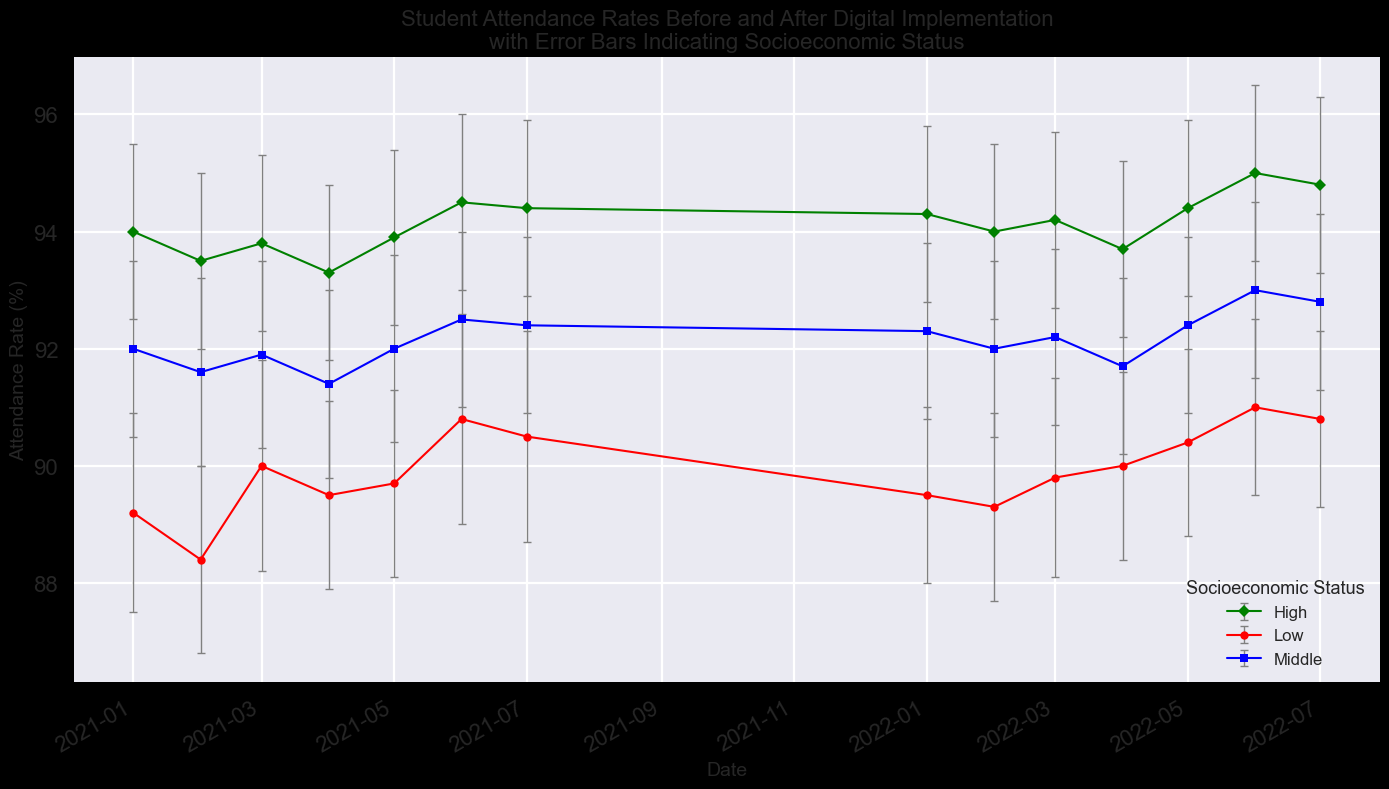What is the general trend in attendance rates for low socioeconomic status students before and after digital implementation? The general trend can be observed by looking at the correlation between dates and attendance rates for low socioeconomic status students. Both before and after digital implementation, the attendance rates show a slight increase month over month. Before implementation (up to July 2021), the rates ranged from approximately 89% to 90.5%. After implementation, the rates improved a bit, ranging from about 89.5% to 92.5%.
Answer: Slight increase How do attendance rates of students from high socioeconomic status compare in July 2021 and July 2022? Attendance rates in July 2021 for high socioeconomic status can be directly compared with July 2022. In July 2021, the mean attendance rate was 94.4%, and in July 2022, it was about 94.8%. Therefore, there's a slight increase in attendance rates for high SES students.
Answer: Increased Which socioeconomic group has the largest error bars? The size of error bars indicates the range of variability in the attendance rates. By visually comparing the error bars across different groups, it can be seen that the High socioeconomic status group has the largest error bars, indicating more variability in the attendance rates.
Answer: High By how much did the mean attendance rate for middle socioeconomic status students change from June 2021 to June 2022? To find the change, compare the mean attendance rate in June 2021 (about 92.5%) to June 2022 (about 93.0%). Calculate the difference: 93.0% - 92.5% = 0.5%.
Answer: 0.5% What is the average mean attendance rate of high socioeconomic status students over the entire period shown? To calculate the average, sum the mean attendance rates for high SES students from January 2021 to July 2022 and then divide by the number of data points. The rates are: 94.0%, 93.5%, 93.8%, 93.3%, 93.9%, 94.5%, 94.4%, 94.3%, 94.0%, 94.2%, 93.7%, 94.4%, 95.0%, 94.8%. The sum is 1329.8 and there are 14 data points, so the average is 1329.8 / 14 = 94.27%.
Answer: 94.27% Which month had the lowest mean attendance rate for low socioeconomic status students after digital implementation? Analyze the months post-digital implementation (starting January 2022) for low SES students. The mean attendance rates for these months are: January (89.5%), February (89.3%), March (89.8%), April (90.0%), May (90.4%), June (91.0%), July (90.8%). The lowest rate is in February 2022 with 89.3%.
Answer: February 2022 Between January 2021 and January 2022, which socioeconomic group showed the greatest improvement in mean attendance rate? Compare the mean attendance rates from January 2021 to January 2022 for each group. Low SES: 89.2% to 89.5%, increase of 0.3%; Middle SES: 92.0% to 92.3%, increase of 0.3%; High SES: 94.0% to 94.3%, increase of 0.3%. All groups show the same improvement of 0.3%, indicating no single group showed greater improvement than the others.
Answer: No difference 